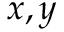Convert formula to latex. <formula><loc_0><loc_0><loc_500><loc_500>x , y</formula> 